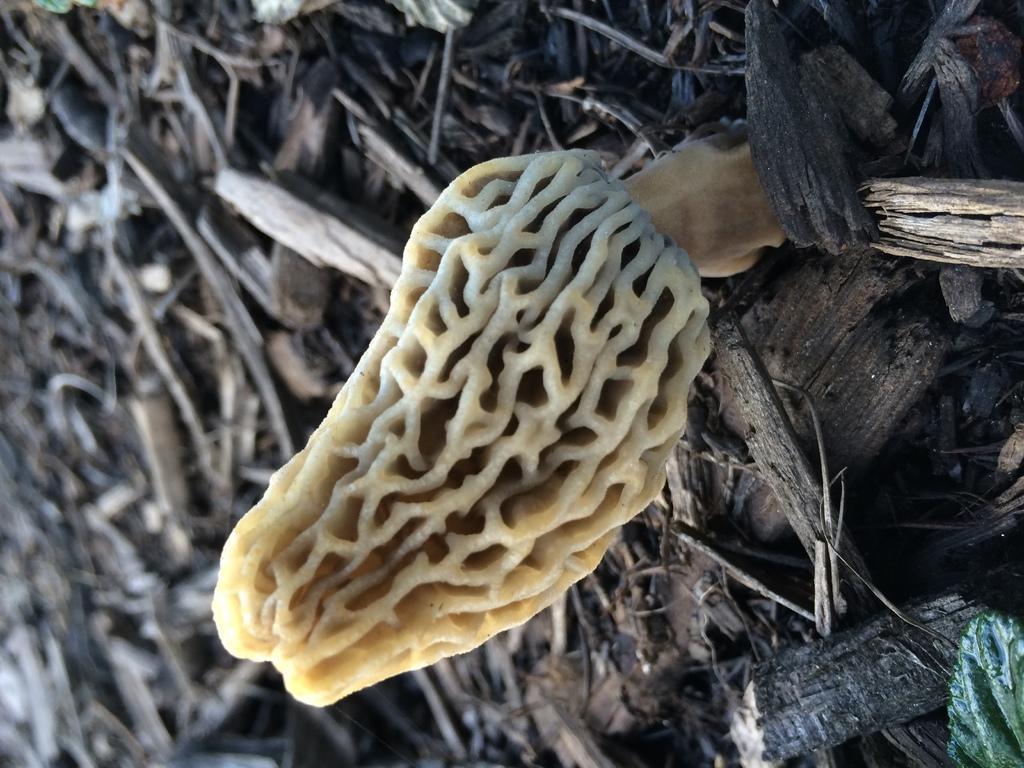Please provide a concise description of this image. In this image I can see something on the ground. I can also see some wooden pieces on the ground. 